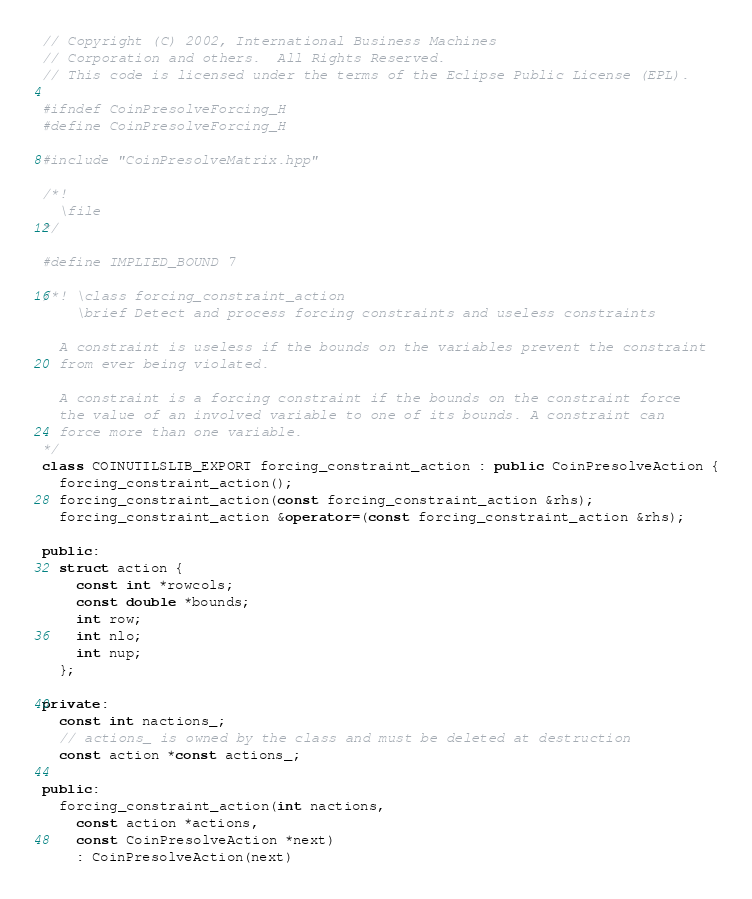<code> <loc_0><loc_0><loc_500><loc_500><_C++_>// Copyright (C) 2002, International Business Machines
// Corporation and others.  All Rights Reserved.
// This code is licensed under the terms of the Eclipse Public License (EPL).

#ifndef CoinPresolveForcing_H
#define CoinPresolveForcing_H

#include "CoinPresolveMatrix.hpp"

/*!
  \file
*/

#define IMPLIED_BOUND 7

/*! \class forcing_constraint_action
    \brief Detect and process forcing constraints and useless constraints

  A constraint is useless if the bounds on the variables prevent the constraint
  from ever being violated.

  A constraint is a forcing constraint if the bounds on the constraint force
  the value of an involved variable to one of its bounds. A constraint can
  force more than one variable.
*/
class COINUTILSLIB_EXPORT forcing_constraint_action : public CoinPresolveAction {
  forcing_constraint_action();
  forcing_constraint_action(const forcing_constraint_action &rhs);
  forcing_constraint_action &operator=(const forcing_constraint_action &rhs);

public:
  struct action {
    const int *rowcols;
    const double *bounds;
    int row;
    int nlo;
    int nup;
  };

private:
  const int nactions_;
  // actions_ is owned by the class and must be deleted at destruction
  const action *const actions_;

public:
  forcing_constraint_action(int nactions,
    const action *actions,
    const CoinPresolveAction *next)
    : CoinPresolveAction(next)</code> 